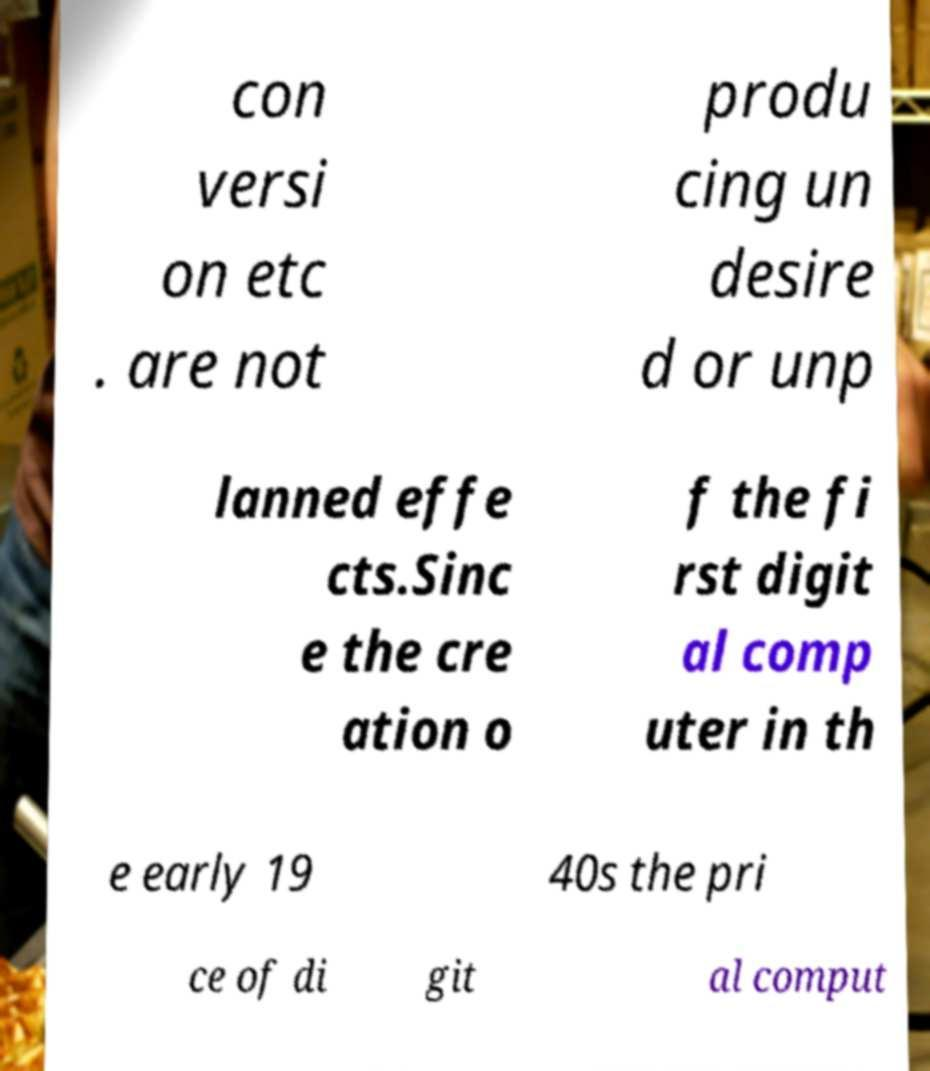Could you extract and type out the text from this image? con versi on etc . are not produ cing un desire d or unp lanned effe cts.Sinc e the cre ation o f the fi rst digit al comp uter in th e early 19 40s the pri ce of di git al comput 